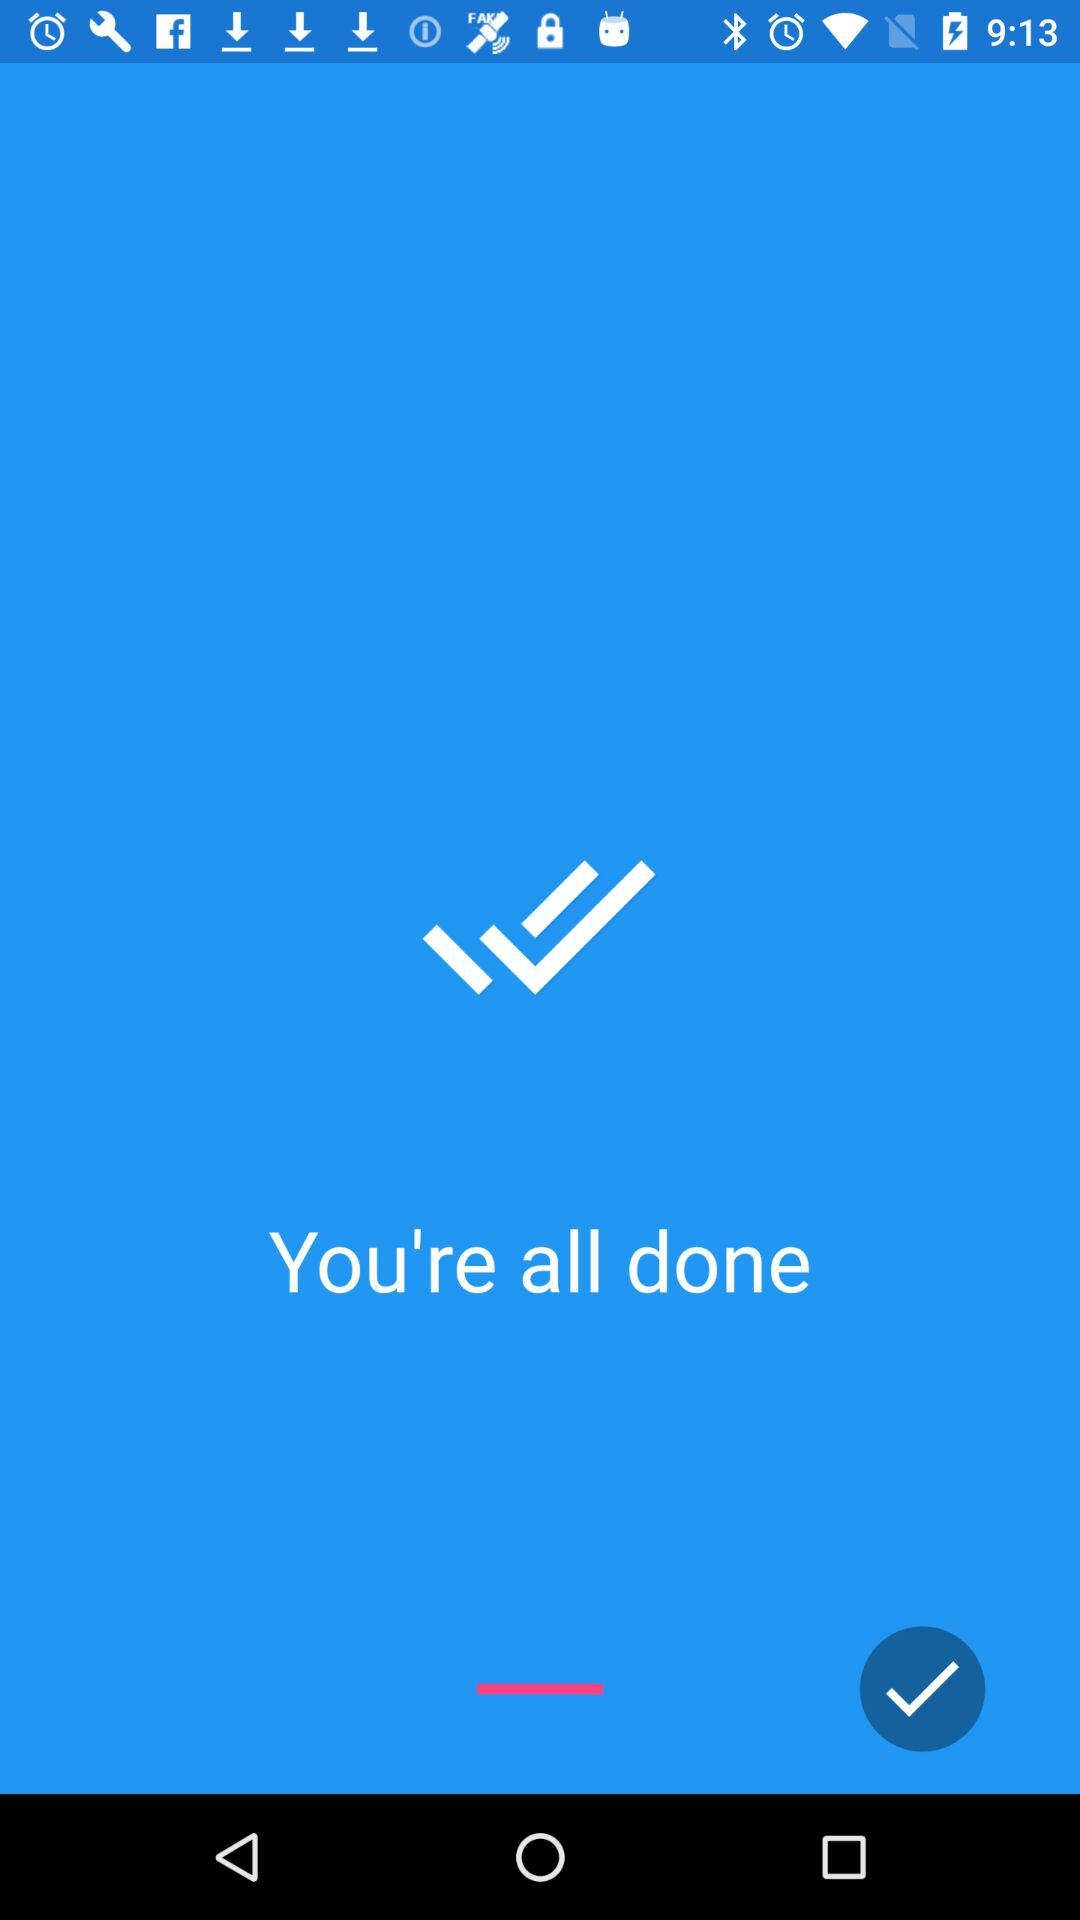How many check marks are there?
Answer the question using a single word or phrase. 2 